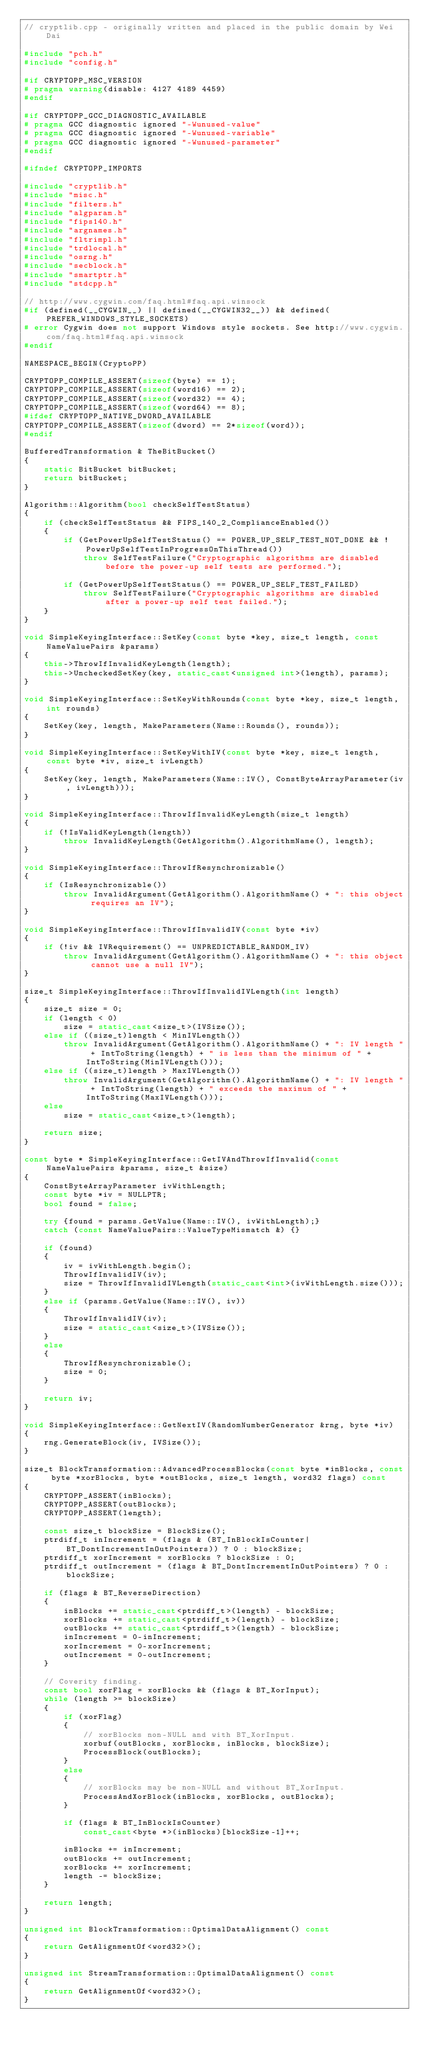<code> <loc_0><loc_0><loc_500><loc_500><_C++_>// cryptlib.cpp - originally written and placed in the public domain by Wei Dai

#include "pch.h"
#include "config.h"

#if CRYPTOPP_MSC_VERSION
# pragma warning(disable: 4127 4189 4459)
#endif

#if CRYPTOPP_GCC_DIAGNOSTIC_AVAILABLE
# pragma GCC diagnostic ignored "-Wunused-value"
# pragma GCC diagnostic ignored "-Wunused-variable"
# pragma GCC diagnostic ignored "-Wunused-parameter"
#endif

#ifndef CRYPTOPP_IMPORTS

#include "cryptlib.h"
#include "misc.h"
#include "filters.h"
#include "algparam.h"
#include "fips140.h"
#include "argnames.h"
#include "fltrimpl.h"
#include "trdlocal.h"
#include "osrng.h"
#include "secblock.h"
#include "smartptr.h"
#include "stdcpp.h"

// http://www.cygwin.com/faq.html#faq.api.winsock
#if (defined(__CYGWIN__) || defined(__CYGWIN32__)) && defined(PREFER_WINDOWS_STYLE_SOCKETS)
# error Cygwin does not support Windows style sockets. See http://www.cygwin.com/faq.html#faq.api.winsock
#endif

NAMESPACE_BEGIN(CryptoPP)

CRYPTOPP_COMPILE_ASSERT(sizeof(byte) == 1);
CRYPTOPP_COMPILE_ASSERT(sizeof(word16) == 2);
CRYPTOPP_COMPILE_ASSERT(sizeof(word32) == 4);
CRYPTOPP_COMPILE_ASSERT(sizeof(word64) == 8);
#ifdef CRYPTOPP_NATIVE_DWORD_AVAILABLE
CRYPTOPP_COMPILE_ASSERT(sizeof(dword) == 2*sizeof(word));
#endif

BufferedTransformation & TheBitBucket()
{
	static BitBucket bitBucket;
	return bitBucket;
}

Algorithm::Algorithm(bool checkSelfTestStatus)
{
	if (checkSelfTestStatus && FIPS_140_2_ComplianceEnabled())
	{
		if (GetPowerUpSelfTestStatus() == POWER_UP_SELF_TEST_NOT_DONE && !PowerUpSelfTestInProgressOnThisThread())
			throw SelfTestFailure("Cryptographic algorithms are disabled before the power-up self tests are performed.");

		if (GetPowerUpSelfTestStatus() == POWER_UP_SELF_TEST_FAILED)
			throw SelfTestFailure("Cryptographic algorithms are disabled after a power-up self test failed.");
	}
}

void SimpleKeyingInterface::SetKey(const byte *key, size_t length, const NameValuePairs &params)
{
	this->ThrowIfInvalidKeyLength(length);
	this->UncheckedSetKey(key, static_cast<unsigned int>(length), params);
}

void SimpleKeyingInterface::SetKeyWithRounds(const byte *key, size_t length, int rounds)
{
	SetKey(key, length, MakeParameters(Name::Rounds(), rounds));
}

void SimpleKeyingInterface::SetKeyWithIV(const byte *key, size_t length, const byte *iv, size_t ivLength)
{
	SetKey(key, length, MakeParameters(Name::IV(), ConstByteArrayParameter(iv, ivLength)));
}

void SimpleKeyingInterface::ThrowIfInvalidKeyLength(size_t length)
{
	if (!IsValidKeyLength(length))
		throw InvalidKeyLength(GetAlgorithm().AlgorithmName(), length);
}

void SimpleKeyingInterface::ThrowIfResynchronizable()
{
	if (IsResynchronizable())
		throw InvalidArgument(GetAlgorithm().AlgorithmName() + ": this object requires an IV");
}

void SimpleKeyingInterface::ThrowIfInvalidIV(const byte *iv)
{
	if (!iv && IVRequirement() == UNPREDICTABLE_RANDOM_IV)
		throw InvalidArgument(GetAlgorithm().AlgorithmName() + ": this object cannot use a null IV");
}

size_t SimpleKeyingInterface::ThrowIfInvalidIVLength(int length)
{
	size_t size = 0;
	if (length < 0)
		size = static_cast<size_t>(IVSize());
	else if ((size_t)length < MinIVLength())
		throw InvalidArgument(GetAlgorithm().AlgorithmName() + ": IV length " + IntToString(length) + " is less than the minimum of " + IntToString(MinIVLength()));
	else if ((size_t)length > MaxIVLength())
		throw InvalidArgument(GetAlgorithm().AlgorithmName() + ": IV length " + IntToString(length) + " exceeds the maximum of " + IntToString(MaxIVLength()));
	else
		size = static_cast<size_t>(length);

	return size;
}

const byte * SimpleKeyingInterface::GetIVAndThrowIfInvalid(const NameValuePairs &params, size_t &size)
{
	ConstByteArrayParameter ivWithLength;
	const byte *iv = NULLPTR;
	bool found = false;

	try {found = params.GetValue(Name::IV(), ivWithLength);}
	catch (const NameValuePairs::ValueTypeMismatch &) {}

	if (found)
	{
		iv = ivWithLength.begin();
		ThrowIfInvalidIV(iv);
		size = ThrowIfInvalidIVLength(static_cast<int>(ivWithLength.size()));
	}
	else if (params.GetValue(Name::IV(), iv))
	{
		ThrowIfInvalidIV(iv);
		size = static_cast<size_t>(IVSize());
	}
	else
	{
		ThrowIfResynchronizable();
		size = 0;
	}

	return iv;
}

void SimpleKeyingInterface::GetNextIV(RandomNumberGenerator &rng, byte *iv)
{
	rng.GenerateBlock(iv, IVSize());
}

size_t BlockTransformation::AdvancedProcessBlocks(const byte *inBlocks, const byte *xorBlocks, byte *outBlocks, size_t length, word32 flags) const
{
	CRYPTOPP_ASSERT(inBlocks);
	CRYPTOPP_ASSERT(outBlocks);
	CRYPTOPP_ASSERT(length);

	const size_t blockSize = BlockSize();
	ptrdiff_t inIncrement = (flags & (BT_InBlockIsCounter|BT_DontIncrementInOutPointers)) ? 0 : blockSize;
	ptrdiff_t xorIncrement = xorBlocks ? blockSize : 0;
	ptrdiff_t outIncrement = (flags & BT_DontIncrementInOutPointers) ? 0 : blockSize;

	if (flags & BT_ReverseDirection)
	{
		inBlocks += static_cast<ptrdiff_t>(length) - blockSize;
		xorBlocks += static_cast<ptrdiff_t>(length) - blockSize;
		outBlocks += static_cast<ptrdiff_t>(length) - blockSize;
		inIncrement = 0-inIncrement;
		xorIncrement = 0-xorIncrement;
		outIncrement = 0-outIncrement;
	}

	// Coverity finding.
	const bool xorFlag = xorBlocks && (flags & BT_XorInput);
	while (length >= blockSize)
	{
		if (xorFlag)
		{
			// xorBlocks non-NULL and with BT_XorInput.
			xorbuf(outBlocks, xorBlocks, inBlocks, blockSize);
			ProcessBlock(outBlocks);
		}
		else
		{
			// xorBlocks may be non-NULL and without BT_XorInput.
			ProcessAndXorBlock(inBlocks, xorBlocks, outBlocks);
		}

		if (flags & BT_InBlockIsCounter)
			const_cast<byte *>(inBlocks)[blockSize-1]++;

		inBlocks += inIncrement;
		outBlocks += outIncrement;
		xorBlocks += xorIncrement;
		length -= blockSize;
	}

	return length;
}

unsigned int BlockTransformation::OptimalDataAlignment() const
{
	return GetAlignmentOf<word32>();
}

unsigned int StreamTransformation::OptimalDataAlignment() const
{
	return GetAlignmentOf<word32>();
}
</code> 